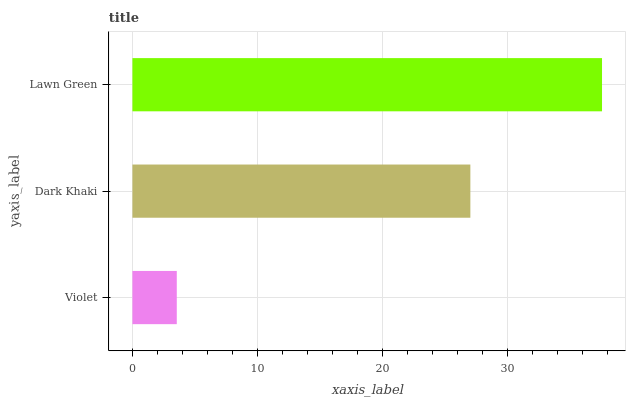Is Violet the minimum?
Answer yes or no. Yes. Is Lawn Green the maximum?
Answer yes or no. Yes. Is Dark Khaki the minimum?
Answer yes or no. No. Is Dark Khaki the maximum?
Answer yes or no. No. Is Dark Khaki greater than Violet?
Answer yes or no. Yes. Is Violet less than Dark Khaki?
Answer yes or no. Yes. Is Violet greater than Dark Khaki?
Answer yes or no. No. Is Dark Khaki less than Violet?
Answer yes or no. No. Is Dark Khaki the high median?
Answer yes or no. Yes. Is Dark Khaki the low median?
Answer yes or no. Yes. Is Lawn Green the high median?
Answer yes or no. No. Is Violet the low median?
Answer yes or no. No. 